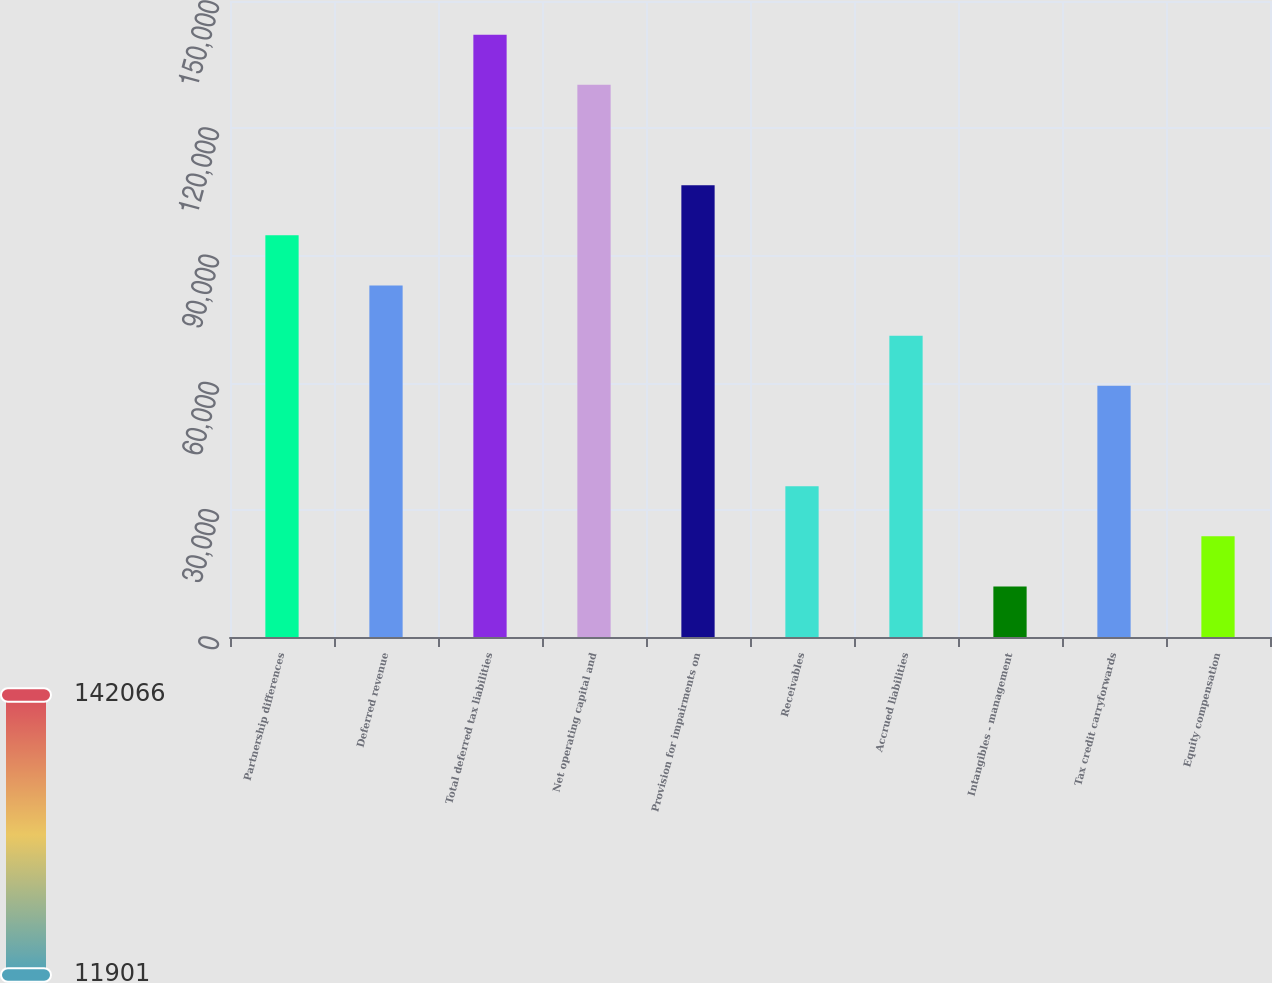Convert chart. <chart><loc_0><loc_0><loc_500><loc_500><bar_chart><fcel>Partnership differences<fcel>Deferred revenue<fcel>Total deferred tax liabilities<fcel>Net operating capital and<fcel>Provision for impairments on<fcel>Receivables<fcel>Accrued liabilities<fcel>Intangibles - management<fcel>Tax credit carryforwards<fcel>Equity compensation<nl><fcel>94733.6<fcel>82900.4<fcel>142066<fcel>130233<fcel>106567<fcel>35567.6<fcel>71067.2<fcel>11901.2<fcel>59234<fcel>23734.4<nl></chart> 